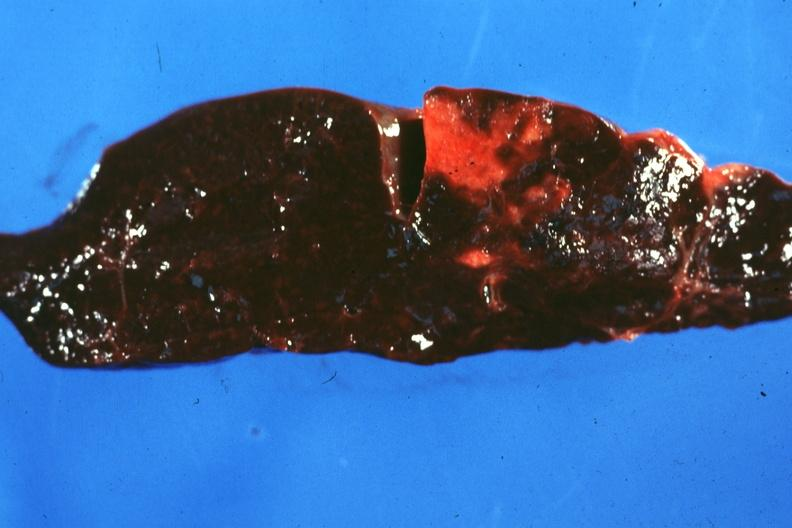what is present?
Answer the question using a single word or phrase. Spleen 